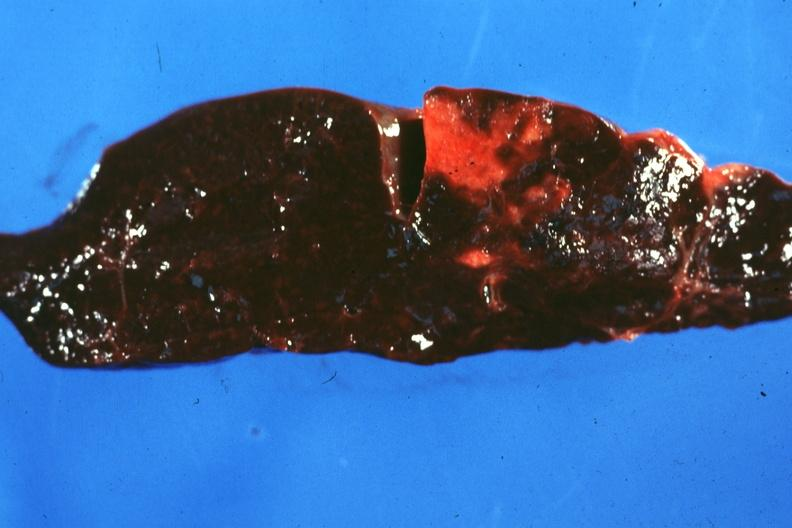what is present?
Answer the question using a single word or phrase. Spleen 